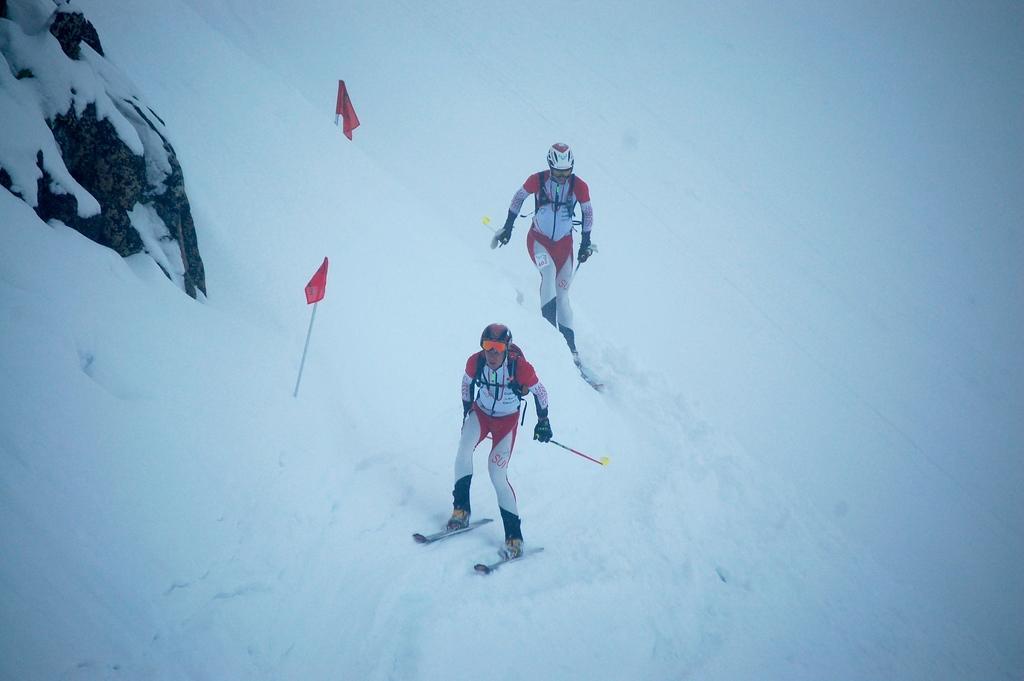Can you describe this image briefly? In this image I can see two persons skating on the snow using sky boards, they are wearing white and red color dress holding two sticks and I can see flags in red color. 